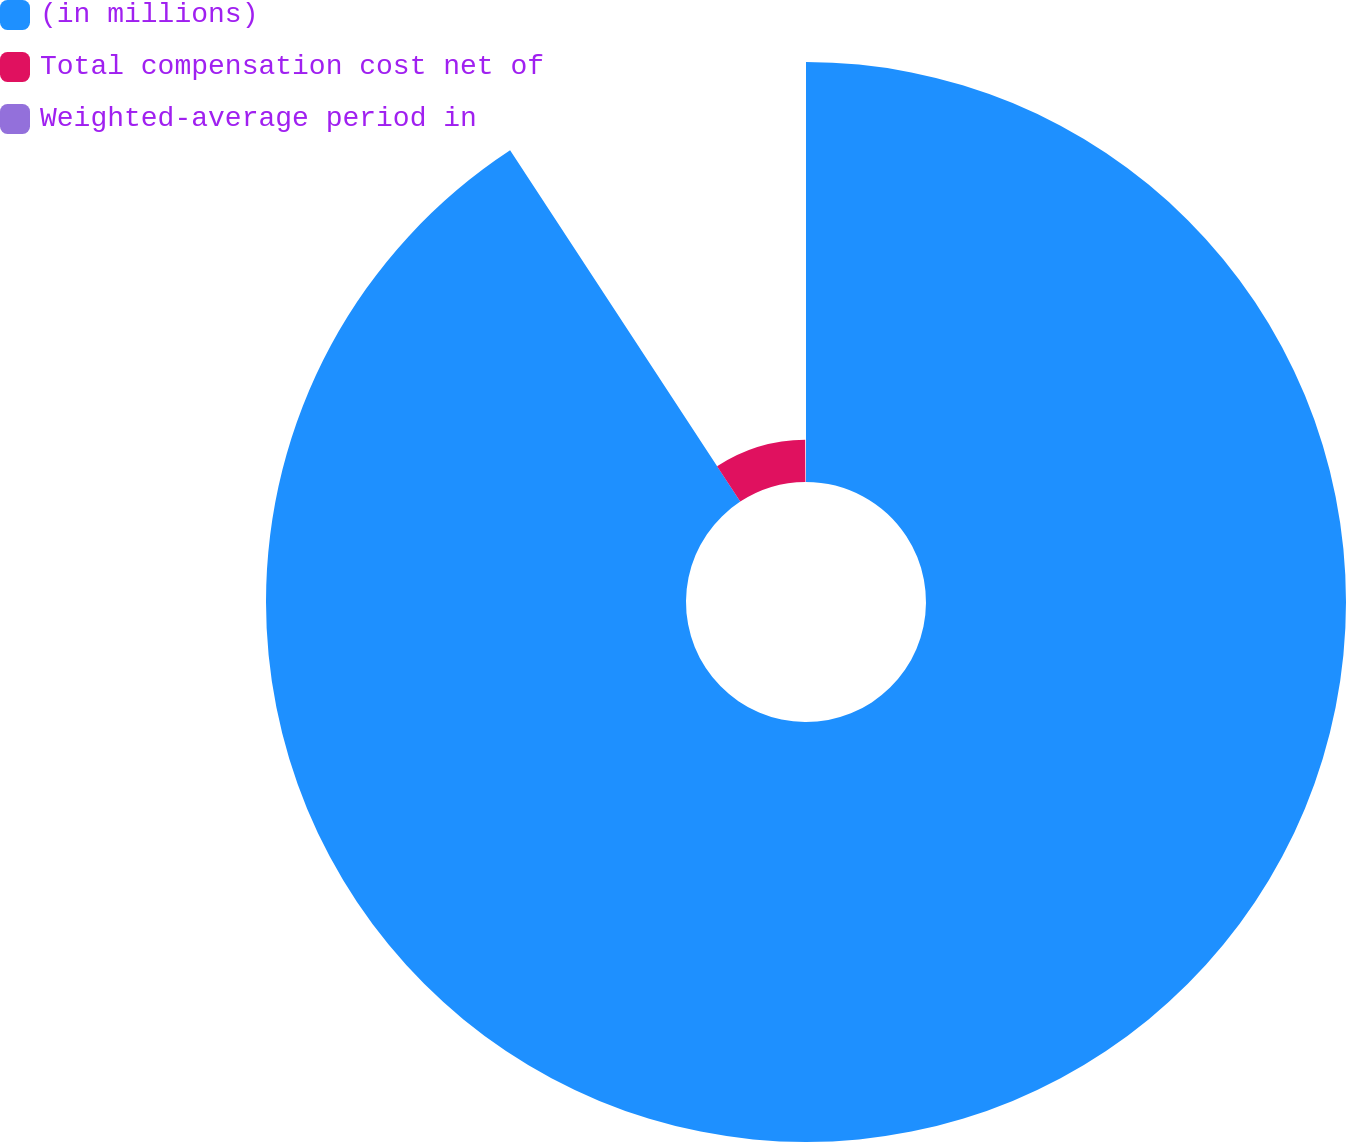Convert chart. <chart><loc_0><loc_0><loc_500><loc_500><pie_chart><fcel>(in millions)<fcel>Total compensation cost net of<fcel>Weighted-average period in<nl><fcel>90.77%<fcel>9.15%<fcel>0.08%<nl></chart> 